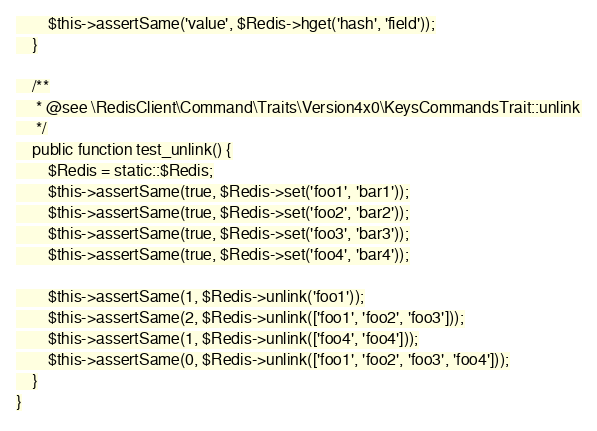<code> <loc_0><loc_0><loc_500><loc_500><_PHP_>        $this->assertSame('value', $Redis->hget('hash', 'field'));
    }

    /**
     * @see \RedisClient\Command\Traits\Version4x0\KeysCommandsTrait::unlink
     */
    public function test_unlink() {
        $Redis = static::$Redis;
        $this->assertSame(true, $Redis->set('foo1', 'bar1'));
        $this->assertSame(true, $Redis->set('foo2', 'bar2'));
        $this->assertSame(true, $Redis->set('foo3', 'bar3'));
        $this->assertSame(true, $Redis->set('foo4', 'bar4'));

        $this->assertSame(1, $Redis->unlink('foo1'));
        $this->assertSame(2, $Redis->unlink(['foo1', 'foo2', 'foo3']));
        $this->assertSame(1, $Redis->unlink(['foo4', 'foo4']));
        $this->assertSame(0, $Redis->unlink(['foo1', 'foo2', 'foo3', 'foo4']));
    }
}
</code> 